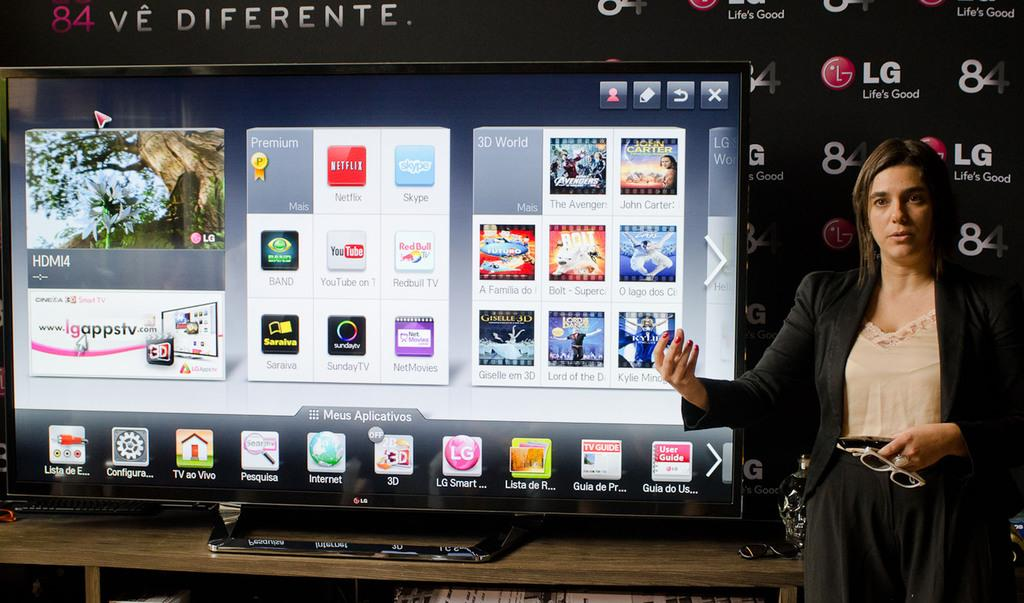<image>
Render a clear and concise summary of the photo. A woman standing next to a large display that says HDM14 on it. 